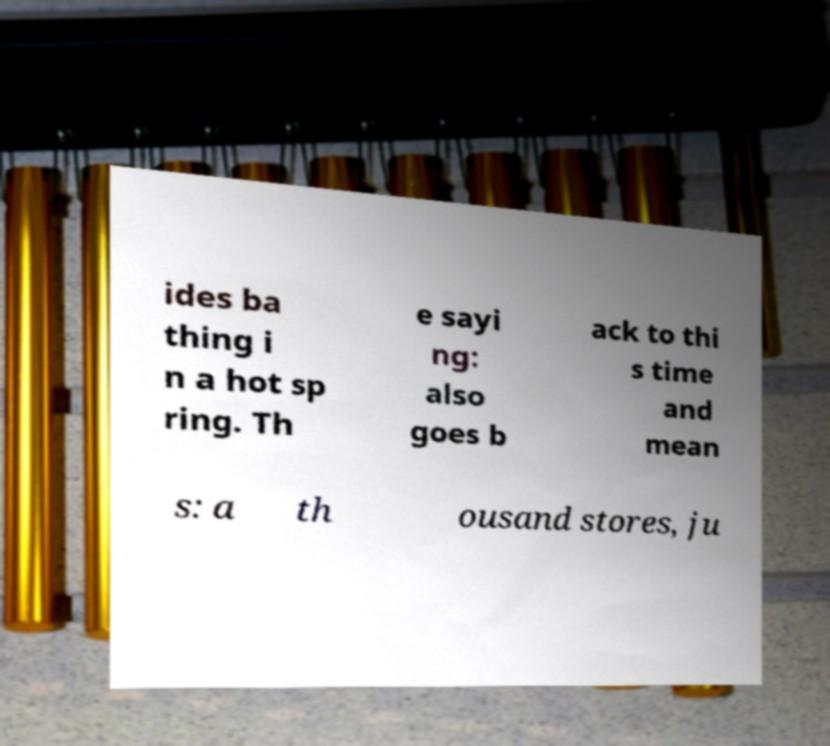Can you accurately transcribe the text from the provided image for me? ides ba thing i n a hot sp ring. Th e sayi ng: also goes b ack to thi s time and mean s: a th ousand stores, ju 